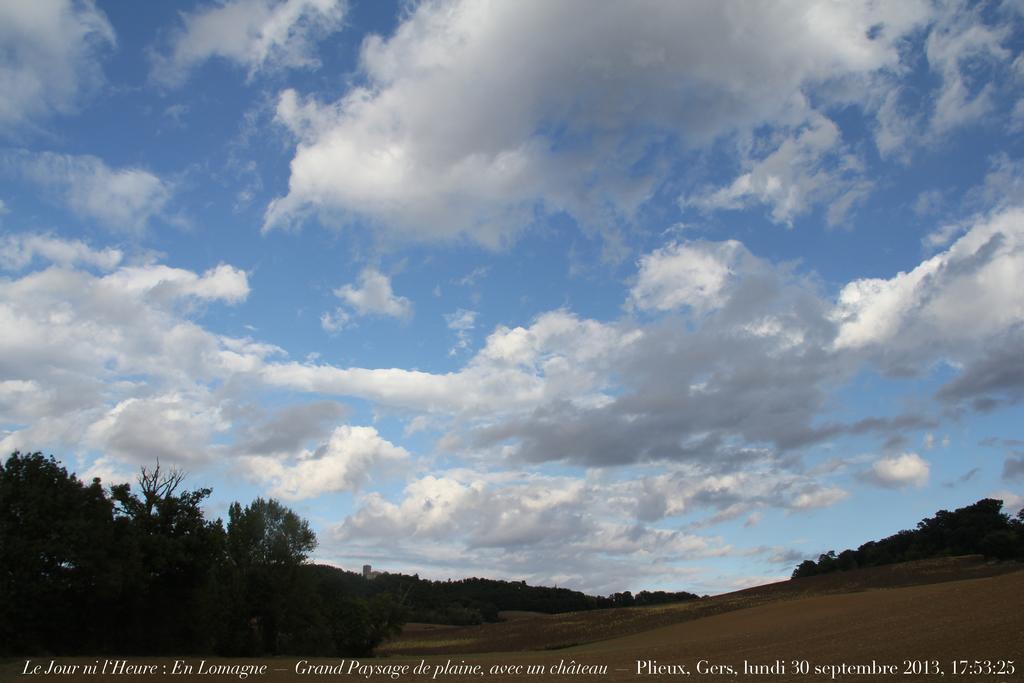Could you give a brief overview of what you see in this image? In this image there are few trees on the land. Top of image there is sky with some clouds. 